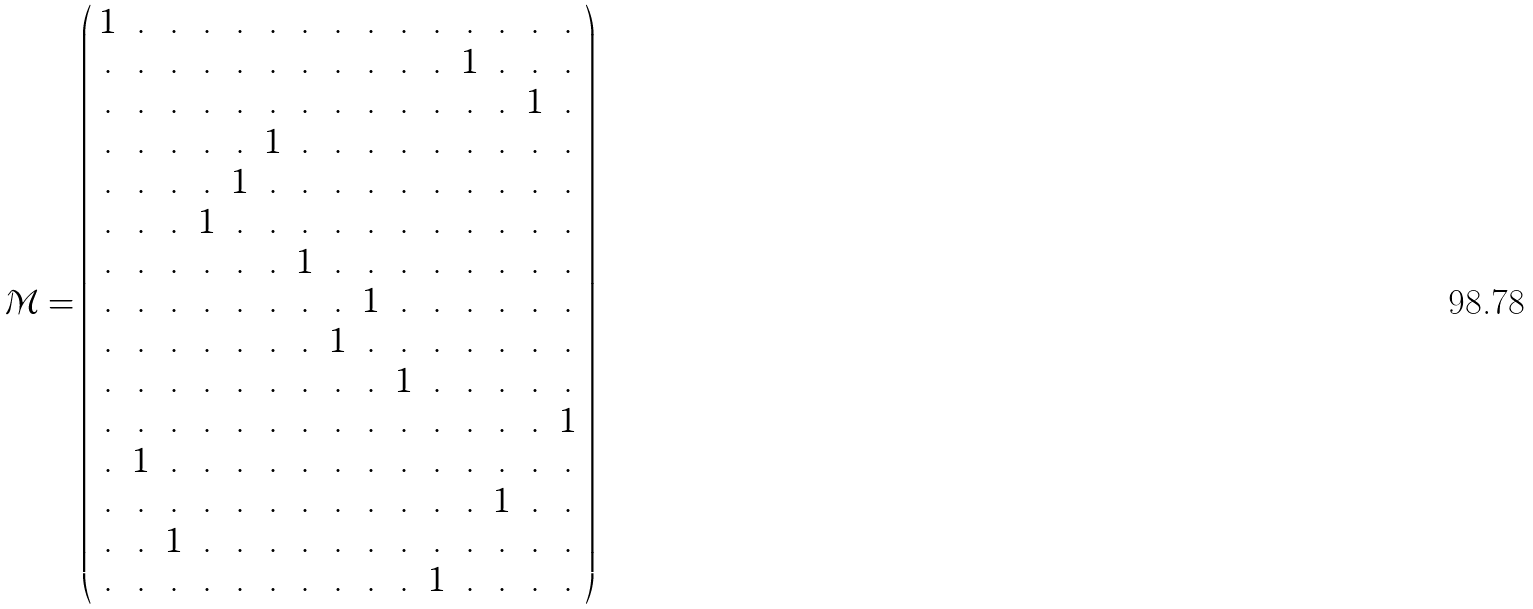<formula> <loc_0><loc_0><loc_500><loc_500>\mathcal { M } = \left ( \begin{array} { c c c c c c c c c c c c c c c } 1 & . & . & . & . & . & . & . & . & . & . & . & . & . & . \\ . & . & . & . & . & . & . & . & . & . & . & 1 & . & . & . \\ . & . & . & . & . & . & . & . & . & . & . & . & . & 1 & . \\ . & . & . & . & . & 1 & . & . & . & . & . & . & . & . & . \\ . & . & . & . & 1 & . & . & . & . & . & . & . & . & . & . \\ . & . & . & 1 & . & . & . & . & . & . & . & . & . & . & . \\ . & . & . & . & . & . & 1 & . & . & . & . & . & . & . & . \\ . & . & . & . & . & . & . & . & 1 & . & . & . & . & . & . \\ . & . & . & . & . & . & . & 1 & . & . & . & . & . & . & . \\ . & . & . & . & . & . & . & . & . & 1 & . & . & . & . & . \\ . & . & . & . & . & . & . & . & . & . & . & . & . & . & 1 \\ . & 1 & . & . & . & . & . & . & . & . & . & . & . & . & . \\ . & . & . & . & . & . & . & . & . & . & . & . & 1 & . & . \\ . & . & 1 & . & . & . & . & . & . & . & . & . & . & . & . \\ . & . & . & . & . & . & . & . & . & . & 1 & . & . & . & . \end{array} \right )</formula> 